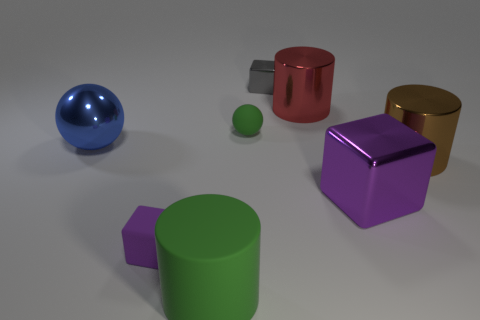Subtract all gray spheres. Subtract all blue cylinders. How many spheres are left? 2 Add 1 big green rubber cylinders. How many objects exist? 9 Subtract all spheres. How many objects are left? 6 Subtract 0 gray cylinders. How many objects are left? 8 Subtract all big blue balls. Subtract all green objects. How many objects are left? 5 Add 8 large purple things. How many large purple things are left? 9 Add 3 gray objects. How many gray objects exist? 4 